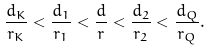Convert formula to latex. <formula><loc_0><loc_0><loc_500><loc_500>\frac { d _ { K } } { r _ { K } } < \frac { d _ { 1 } } { r _ { 1 } } < \frac { d } { r } < \frac { d _ { 2 } } { r _ { 2 } } < \frac { d _ { Q } } { r _ { Q } } .</formula> 